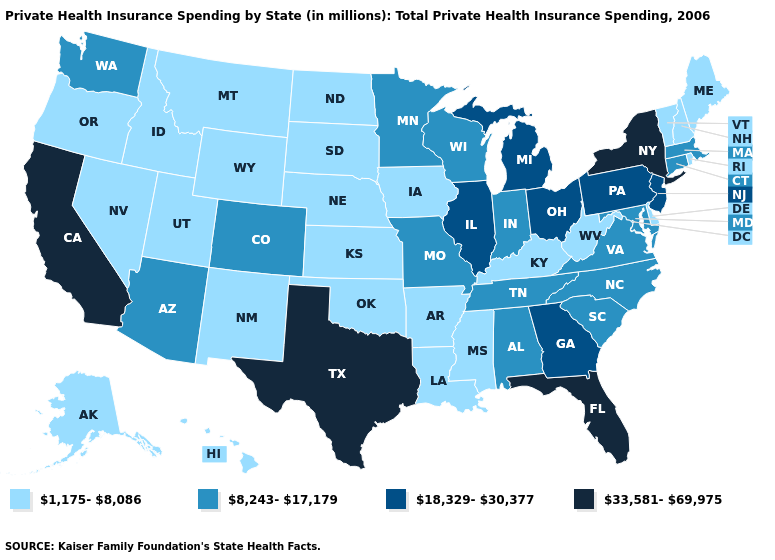Name the states that have a value in the range 18,329-30,377?
Be succinct. Georgia, Illinois, Michigan, New Jersey, Ohio, Pennsylvania. Name the states that have a value in the range 18,329-30,377?
Write a very short answer. Georgia, Illinois, Michigan, New Jersey, Ohio, Pennsylvania. Name the states that have a value in the range 18,329-30,377?
Answer briefly. Georgia, Illinois, Michigan, New Jersey, Ohio, Pennsylvania. Name the states that have a value in the range 8,243-17,179?
Quick response, please. Alabama, Arizona, Colorado, Connecticut, Indiana, Maryland, Massachusetts, Minnesota, Missouri, North Carolina, South Carolina, Tennessee, Virginia, Washington, Wisconsin. Name the states that have a value in the range 33,581-69,975?
Give a very brief answer. California, Florida, New York, Texas. How many symbols are there in the legend?
Quick response, please. 4. What is the lowest value in the MidWest?
Be succinct. 1,175-8,086. What is the lowest value in the USA?
Answer briefly. 1,175-8,086. What is the value of Nebraska?
Be succinct. 1,175-8,086. Which states have the lowest value in the MidWest?
Quick response, please. Iowa, Kansas, Nebraska, North Dakota, South Dakota. What is the value of New Mexico?
Quick response, please. 1,175-8,086. Name the states that have a value in the range 8,243-17,179?
Be succinct. Alabama, Arizona, Colorado, Connecticut, Indiana, Maryland, Massachusetts, Minnesota, Missouri, North Carolina, South Carolina, Tennessee, Virginia, Washington, Wisconsin. Does New York have the highest value in the USA?
Short answer required. Yes. Is the legend a continuous bar?
Write a very short answer. No. Among the states that border Utah , which have the lowest value?
Answer briefly. Idaho, Nevada, New Mexico, Wyoming. 